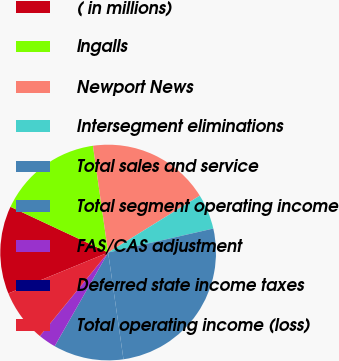Convert chart to OTSL. <chart><loc_0><loc_0><loc_500><loc_500><pie_chart><fcel>( in millions)<fcel>Ingalls<fcel>Newport News<fcel>Intersegment eliminations<fcel>Total sales and service<fcel>Total segment operating income<fcel>FAS/CAS adjustment<fcel>Deferred state income taxes<fcel>Total operating income (loss)<nl><fcel>13.16%<fcel>15.78%<fcel>18.41%<fcel>5.27%<fcel>26.3%<fcel>10.53%<fcel>2.64%<fcel>0.01%<fcel>7.9%<nl></chart> 